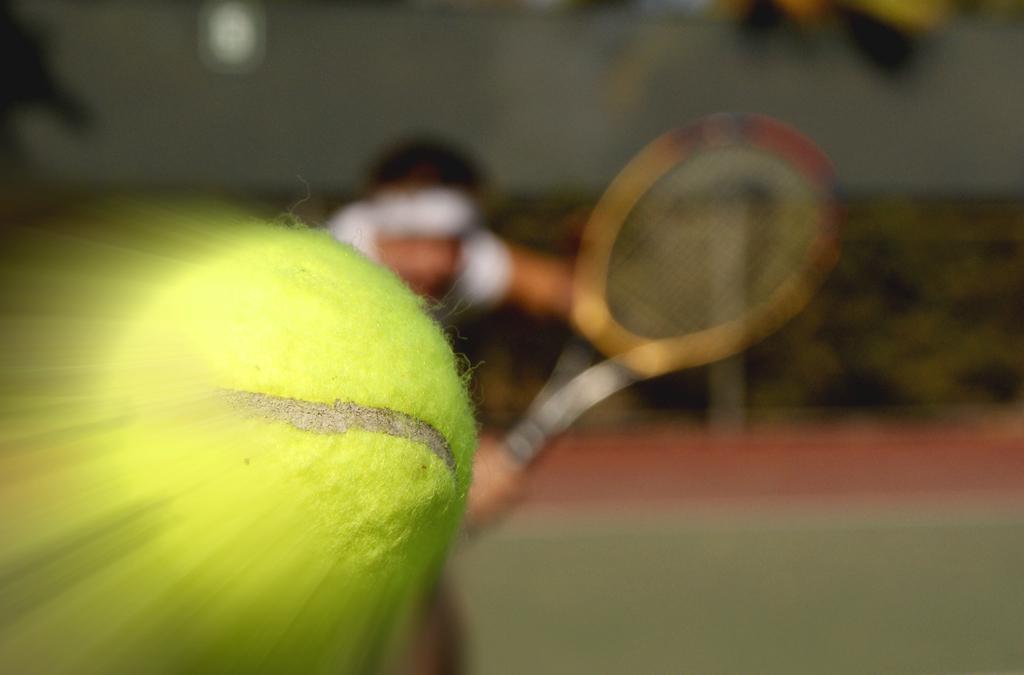Describe this image in one or two sentences. In this image we can see a man is standing on the ground, and holding the racket in the hands, here is the ball, the background is blurry. 